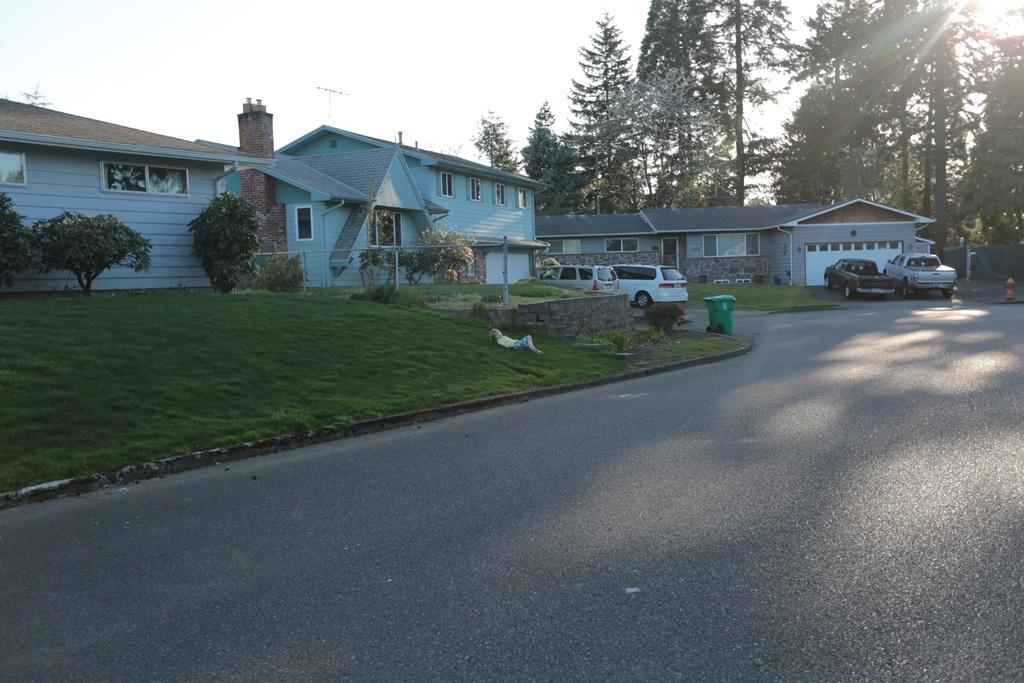What type of structures can be seen in the image? There are houses in the image. What is the landscape in front of the houses? Grassy land is present in front of the houses. What type of vegetation is visible in the image? Plants are visible in the image. What type of vehicles are present in the image? Cars are present in the image. What type of pathway is visible in the image? There is a road in the image. What type of vegetation can be seen in the background of the image? Trees are present in the background of the image. What type of flower is being used as a screwdriver in the image? There is no flower or screwdriver present in the image. 